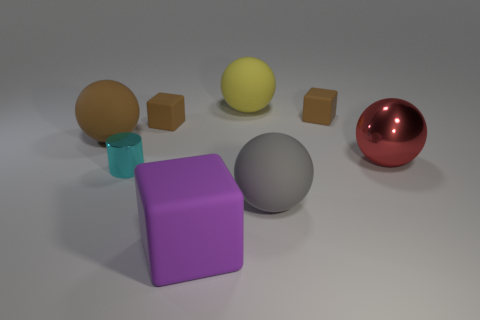Do the big thing left of the cyan object and the large purple rubber object that is on the left side of the big yellow thing have the same shape?
Keep it short and to the point. No. What number of objects are cyan rubber cubes or small cyan shiny cylinders?
Make the answer very short. 1. There is a yellow thing that is the same shape as the large gray rubber object; what size is it?
Keep it short and to the point. Large. Are there more tiny things that are in front of the cyan metallic object than large metallic blocks?
Your answer should be very brief. No. Are the big purple cube and the large brown thing made of the same material?
Provide a succinct answer. Yes. How many objects are either large objects that are right of the yellow rubber thing or metallic objects that are on the left side of the purple block?
Offer a very short reply. 3. What is the color of the shiny object that is the same shape as the big yellow matte thing?
Your answer should be very brief. Red. How many matte cubes have the same color as the large shiny sphere?
Make the answer very short. 0. Is the large metal ball the same color as the big matte block?
Ensure brevity in your answer.  No. What number of things are either matte things left of the gray thing or tiny matte blocks?
Offer a terse response. 5. 